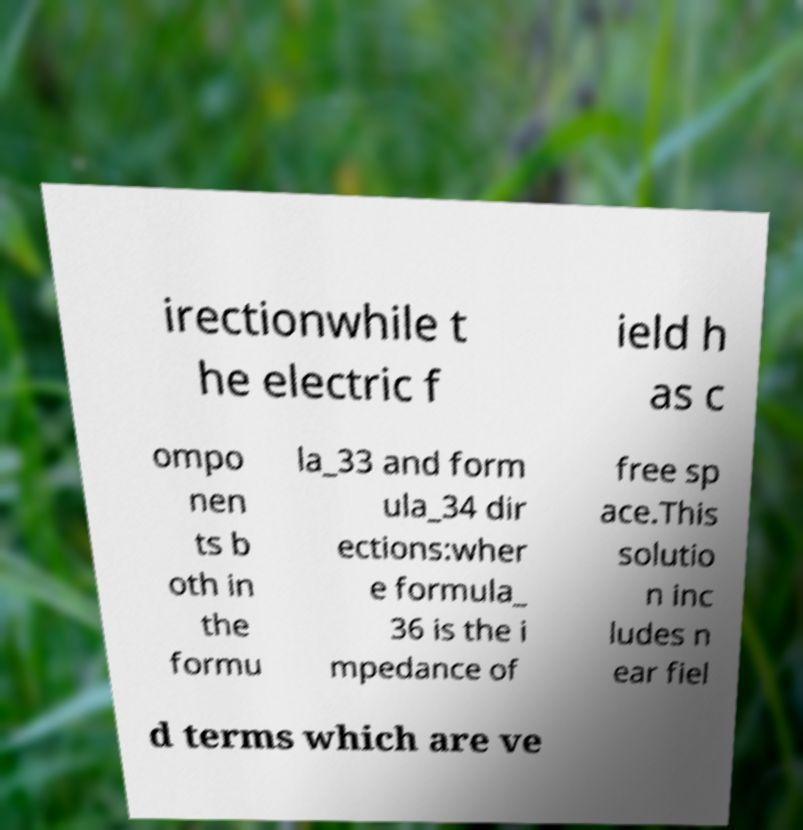For documentation purposes, I need the text within this image transcribed. Could you provide that? irectionwhile t he electric f ield h as c ompo nen ts b oth in the formu la_33 and form ula_34 dir ections:wher e formula_ 36 is the i mpedance of free sp ace.This solutio n inc ludes n ear fiel d terms which are ve 